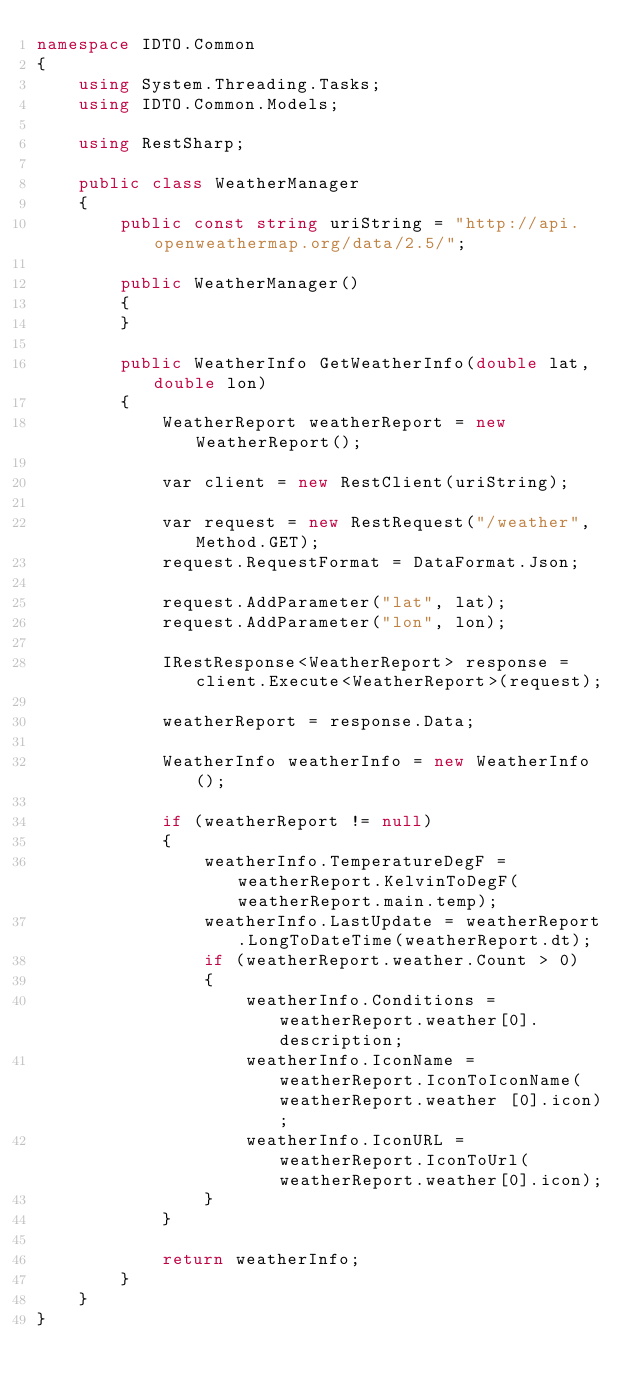Convert code to text. <code><loc_0><loc_0><loc_500><loc_500><_C#_>namespace IDTO.Common
{
    using System.Threading.Tasks;
    using IDTO.Common.Models;

    using RestSharp;

    public class WeatherManager
    {
        public const string uriString = "http://api.openweathermap.org/data/2.5/";

        public WeatherManager()
        {
        }

        public WeatherInfo GetWeatherInfo(double lat, double lon)
        {
            WeatherReport weatherReport = new WeatherReport();

            var client = new RestClient(uriString);

            var request = new RestRequest("/weather", Method.GET);
            request.RequestFormat = DataFormat.Json;

            request.AddParameter("lat", lat);
            request.AddParameter("lon", lon);

            IRestResponse<WeatherReport> response = client.Execute<WeatherReport>(request);

            weatherReport = response.Data;

            WeatherInfo weatherInfo = new WeatherInfo();

            if (weatherReport != null)
            {
                weatherInfo.TemperatureDegF = weatherReport.KelvinToDegF(weatherReport.main.temp);
                weatherInfo.LastUpdate = weatherReport.LongToDateTime(weatherReport.dt);
                if (weatherReport.weather.Count > 0)
                {
                    weatherInfo.Conditions = weatherReport.weather[0].description;
					weatherInfo.IconName = weatherReport.IconToIconName(weatherReport.weather [0].icon);
                    weatherInfo.IconURL = weatherReport.IconToUrl(weatherReport.weather[0].icon);
                }
            }

            return weatherInfo;
        }
    }
}</code> 